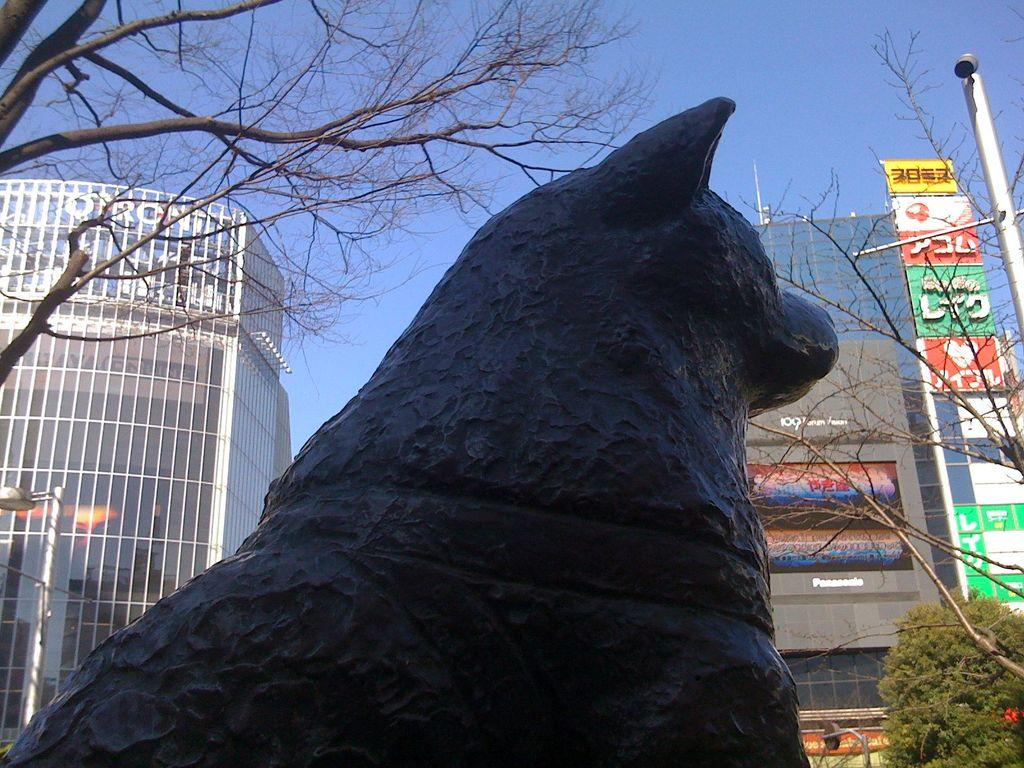What is the main subject in the center of the image? There is a statue in the center of the image. What can be seen in the background of the image? There are buildings, trees, a pole, and the sky visible in the background of the image. Can you tell me how many beads are hanging from the statue in the image? There are no beads present on the statue in the image. What type of request is being made by the statue in the image? The statue is not making any requests in the image, as it is an inanimate object. 